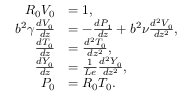<formula> <loc_0><loc_0><loc_500><loc_500>\begin{array} { r l } { { R } _ { 0 } { V } _ { 0 } } & { = 1 , } \\ { b ^ { 2 } \gamma \frac { d { V } _ { 0 } } { d z } } & { = - \frac { d { P } _ { 1 } } { d z } + b ^ { 2 } \nu \frac { d ^ { 2 } { V } _ { 0 } } { d z ^ { 2 } } , } \\ { \frac { d { T } _ { 0 } } { d z } } & { = \frac { d ^ { 2 } { T } _ { 0 } } { d z ^ { 2 } } , } \\ { \frac { d { Y } _ { 0 } } { d z } } & { = \frac { 1 } { L e } \frac { d ^ { 2 } { Y } _ { 0 } } { d z ^ { 2 } } , } \\ { { P } _ { 0 } } & { = { R } _ { 0 } { T } _ { 0 } . } \end{array}</formula> 